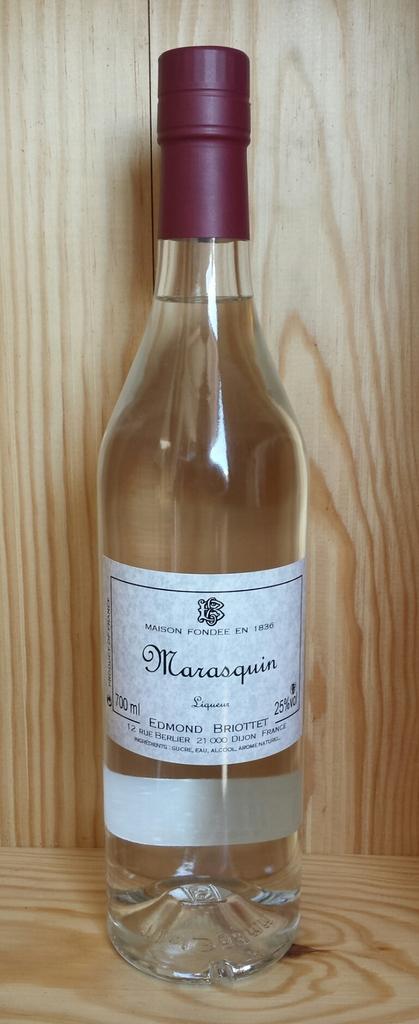Describe this image in one or two sentences. There is a white glass bottle in this picture which is named as MARASQUIN , which is kept in the brown wooden box. 